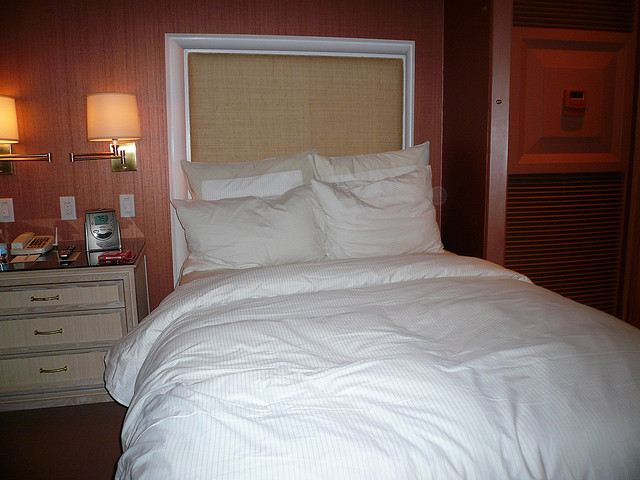What kind of decoration can you see in the bedroom? The bedroom's decor is minimalistic, with a focus on simplicity and elegance. There's a textured headboard that adds a touch of depth to the space, while the lamps serve both functional and decorative purposes. The absence of paintings or pictures contributes to the room's serene and uncluttered aesthetic. 